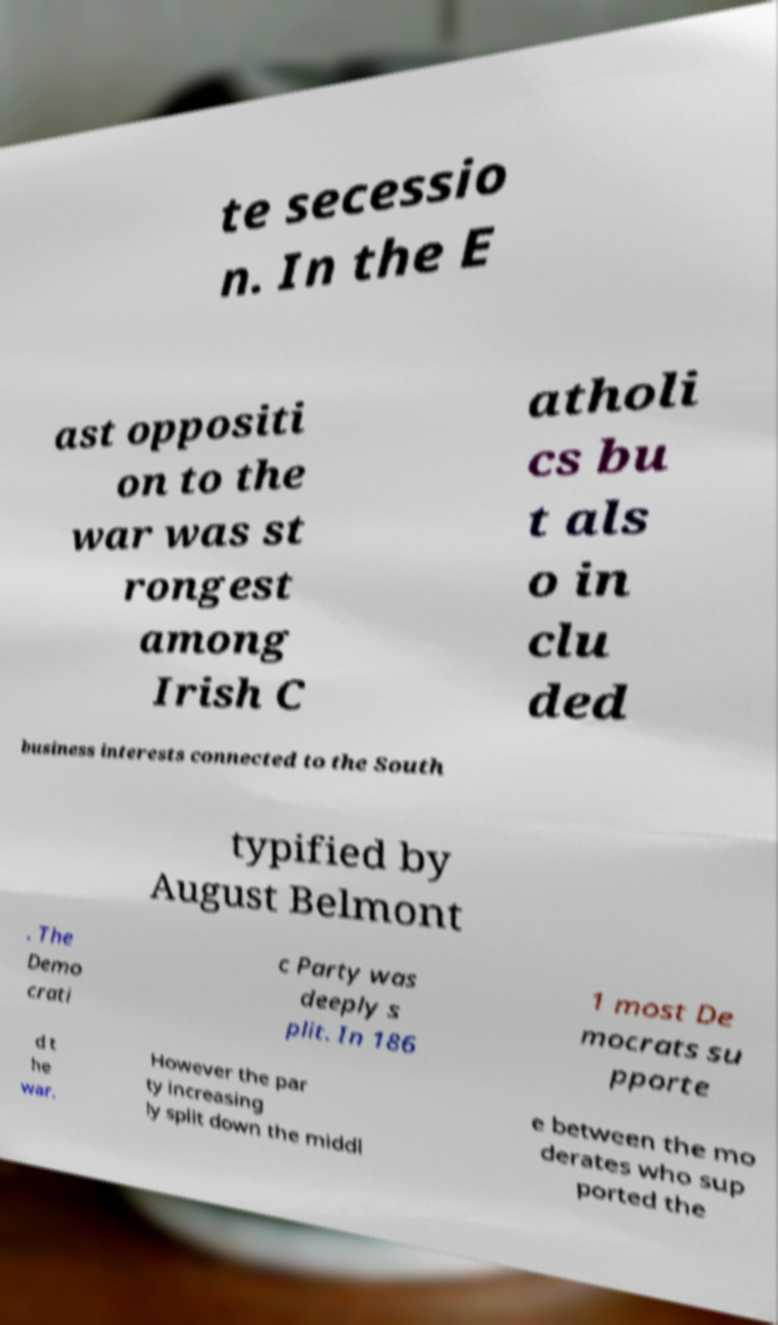Please read and relay the text visible in this image. What does it say? te secessio n. In the E ast oppositi on to the war was st rongest among Irish C atholi cs bu t als o in clu ded business interests connected to the South typified by August Belmont . The Demo crati c Party was deeply s plit. In 186 1 most De mocrats su pporte d t he war. However the par ty increasing ly split down the middl e between the mo derates who sup ported the 